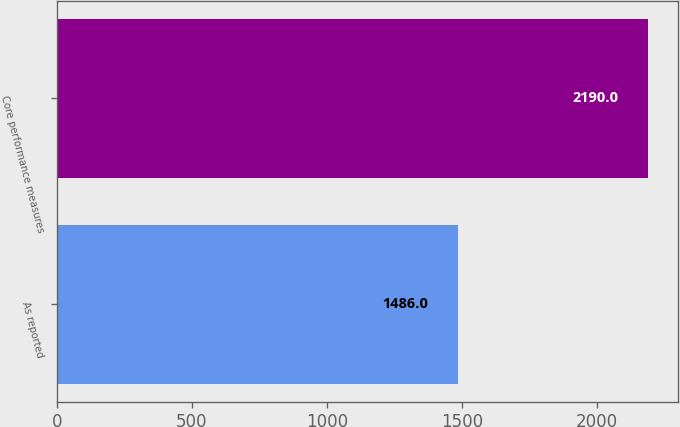<chart> <loc_0><loc_0><loc_500><loc_500><bar_chart><fcel>As reported<fcel>Core performance measures<nl><fcel>1486<fcel>2190<nl></chart> 